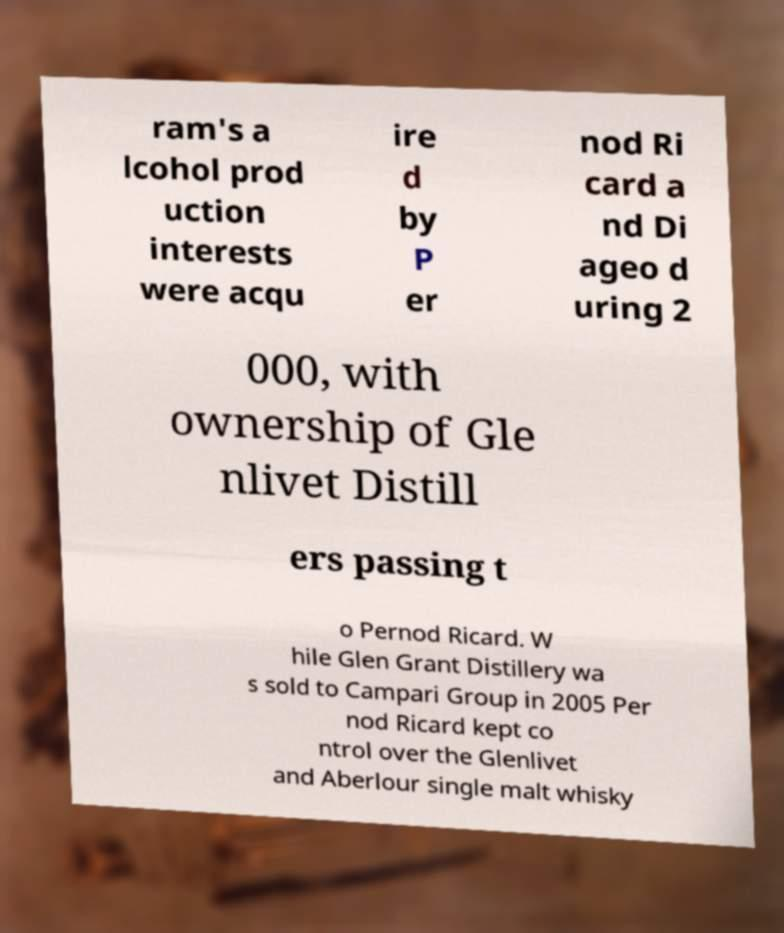Can you accurately transcribe the text from the provided image for me? ram's a lcohol prod uction interests were acqu ire d by P er nod Ri card a nd Di ageo d uring 2 000, with ownership of Gle nlivet Distill ers passing t o Pernod Ricard. W hile Glen Grant Distillery wa s sold to Campari Group in 2005 Per nod Ricard kept co ntrol over the Glenlivet and Aberlour single malt whisky 